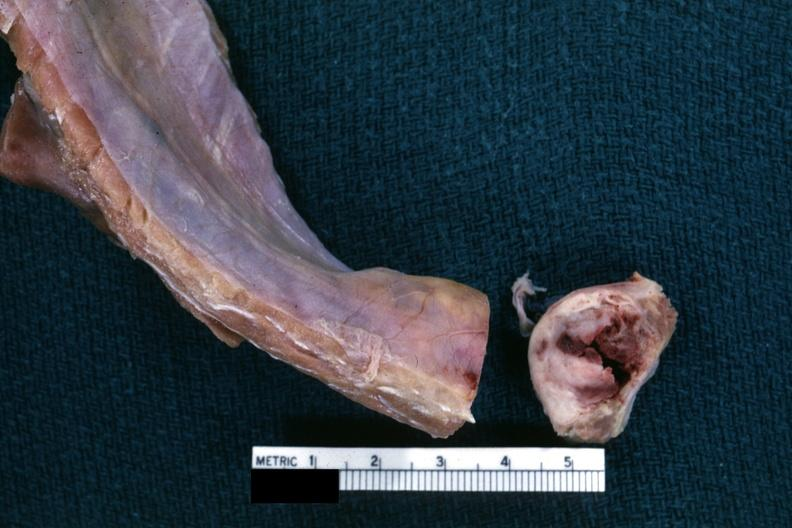does lymphoma show obvious nodular rib lesion cross sectioned to show white neoplasm with central hemorrhage?
Answer the question using a single word or phrase. No 